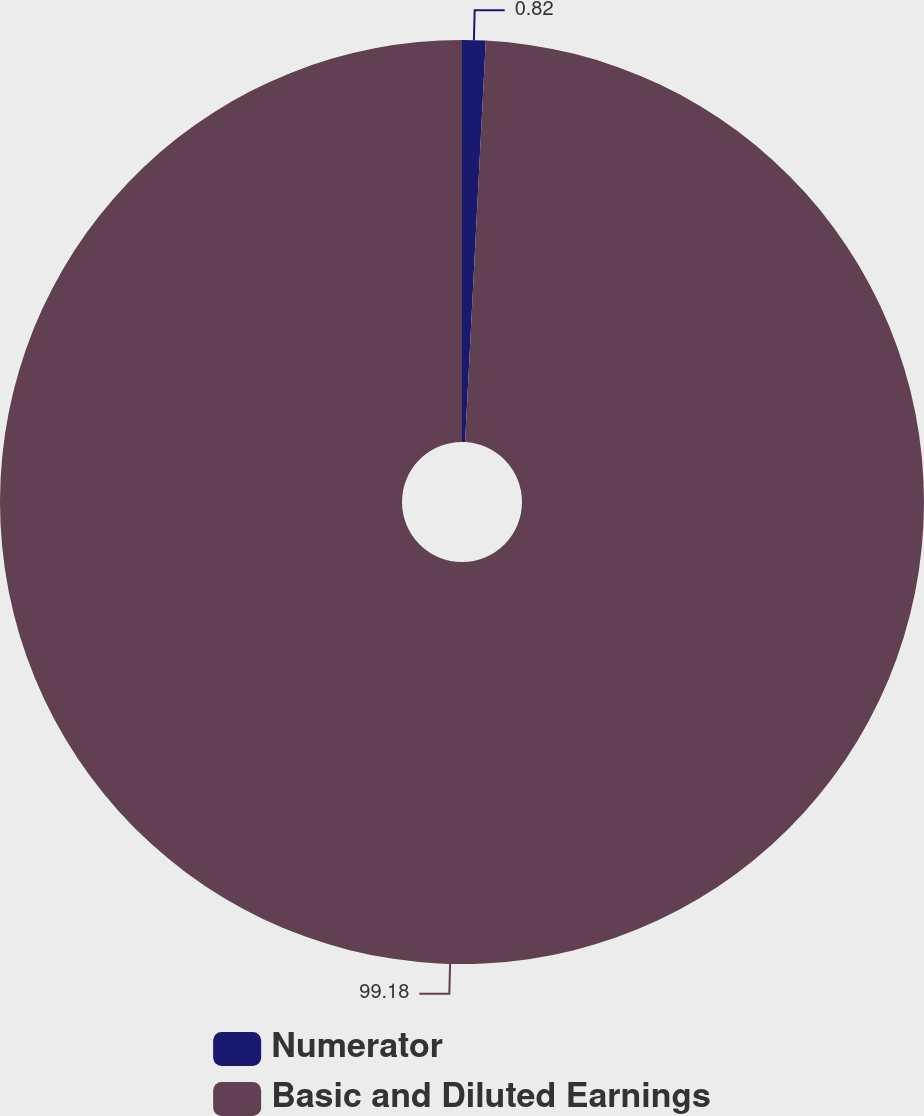Convert chart. <chart><loc_0><loc_0><loc_500><loc_500><pie_chart><fcel>Numerator<fcel>Basic and Diluted Earnings<nl><fcel>0.82%<fcel>99.18%<nl></chart> 